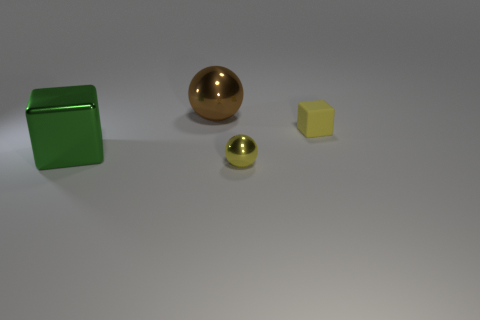Add 3 small blue rubber cubes. How many objects exist? 7 Subtract 1 spheres. How many spheres are left? 1 Subtract all yellow matte objects. Subtract all large balls. How many objects are left? 2 Add 3 tiny yellow shiny balls. How many tiny yellow shiny balls are left? 4 Add 4 big brown balls. How many big brown balls exist? 5 Subtract 0 red blocks. How many objects are left? 4 Subtract all purple spheres. Subtract all red cylinders. How many spheres are left? 2 Subtract all yellow cylinders. How many green cubes are left? 1 